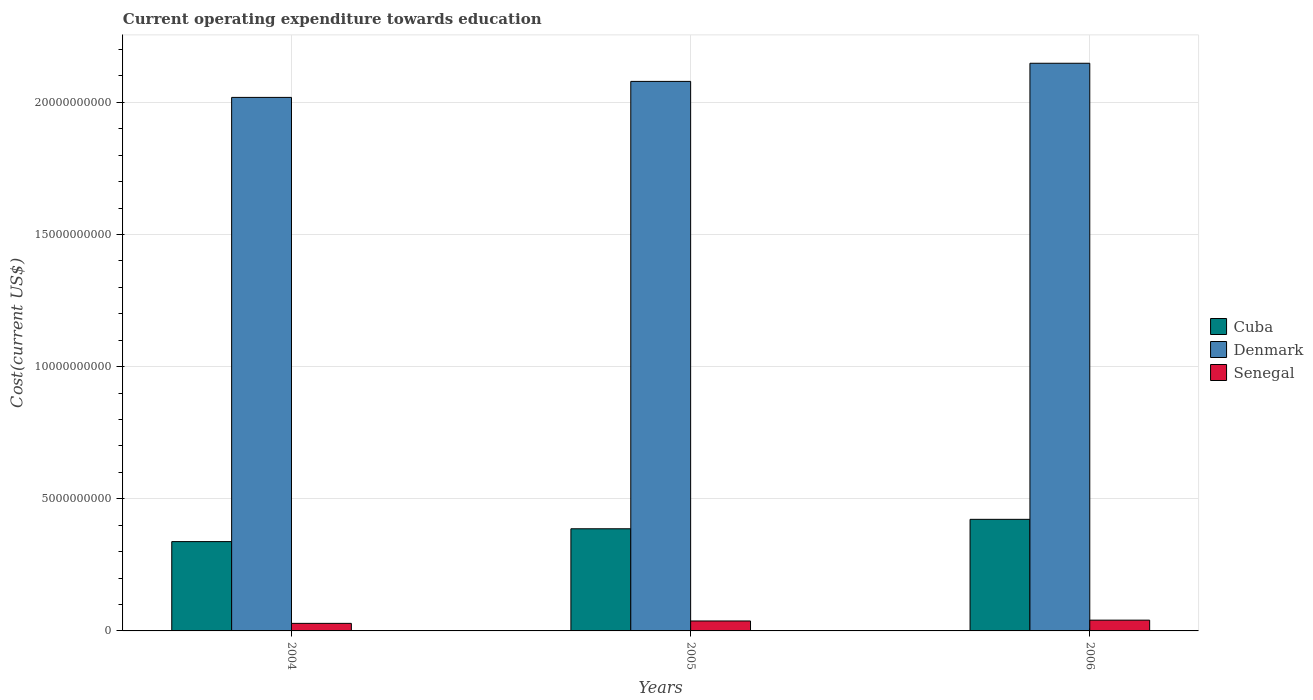How many different coloured bars are there?
Your answer should be compact. 3. How many groups of bars are there?
Provide a succinct answer. 3. Are the number of bars per tick equal to the number of legend labels?
Ensure brevity in your answer.  Yes. How many bars are there on the 3rd tick from the right?
Offer a very short reply. 3. What is the expenditure towards education in Denmark in 2004?
Provide a short and direct response. 2.02e+1. Across all years, what is the maximum expenditure towards education in Senegal?
Provide a succinct answer. 4.08e+08. Across all years, what is the minimum expenditure towards education in Cuba?
Offer a terse response. 3.38e+09. What is the total expenditure towards education in Cuba in the graph?
Your answer should be very brief. 1.15e+1. What is the difference between the expenditure towards education in Denmark in 2005 and that in 2006?
Offer a terse response. -6.87e+08. What is the difference between the expenditure towards education in Denmark in 2005 and the expenditure towards education in Cuba in 2006?
Offer a terse response. 1.66e+1. What is the average expenditure towards education in Denmark per year?
Provide a short and direct response. 2.08e+1. In the year 2004, what is the difference between the expenditure towards education in Cuba and expenditure towards education in Senegal?
Provide a succinct answer. 3.09e+09. What is the ratio of the expenditure towards education in Cuba in 2004 to that in 2005?
Your answer should be very brief. 0.87. Is the difference between the expenditure towards education in Cuba in 2005 and 2006 greater than the difference between the expenditure towards education in Senegal in 2005 and 2006?
Offer a very short reply. No. What is the difference between the highest and the second highest expenditure towards education in Senegal?
Keep it short and to the point. 3.16e+07. What is the difference between the highest and the lowest expenditure towards education in Cuba?
Make the answer very short. 8.42e+08. What does the 3rd bar from the left in 2004 represents?
Offer a very short reply. Senegal. What does the 3rd bar from the right in 2006 represents?
Provide a short and direct response. Cuba. Is it the case that in every year, the sum of the expenditure towards education in Cuba and expenditure towards education in Senegal is greater than the expenditure towards education in Denmark?
Give a very brief answer. No. How many bars are there?
Offer a very short reply. 9. Are all the bars in the graph horizontal?
Your answer should be very brief. No. Where does the legend appear in the graph?
Make the answer very short. Center right. What is the title of the graph?
Make the answer very short. Current operating expenditure towards education. Does "Ethiopia" appear as one of the legend labels in the graph?
Make the answer very short. No. What is the label or title of the X-axis?
Your answer should be very brief. Years. What is the label or title of the Y-axis?
Your answer should be compact. Cost(current US$). What is the Cost(current US$) of Cuba in 2004?
Provide a short and direct response. 3.38e+09. What is the Cost(current US$) of Denmark in 2004?
Keep it short and to the point. 2.02e+1. What is the Cost(current US$) in Senegal in 2004?
Your response must be concise. 2.86e+08. What is the Cost(current US$) in Cuba in 2005?
Make the answer very short. 3.87e+09. What is the Cost(current US$) of Denmark in 2005?
Make the answer very short. 2.08e+1. What is the Cost(current US$) of Senegal in 2005?
Ensure brevity in your answer.  3.76e+08. What is the Cost(current US$) of Cuba in 2006?
Your answer should be very brief. 4.22e+09. What is the Cost(current US$) of Denmark in 2006?
Offer a terse response. 2.15e+1. What is the Cost(current US$) in Senegal in 2006?
Your response must be concise. 4.08e+08. Across all years, what is the maximum Cost(current US$) in Cuba?
Give a very brief answer. 4.22e+09. Across all years, what is the maximum Cost(current US$) of Denmark?
Your answer should be compact. 2.15e+1. Across all years, what is the maximum Cost(current US$) of Senegal?
Offer a very short reply. 4.08e+08. Across all years, what is the minimum Cost(current US$) in Cuba?
Give a very brief answer. 3.38e+09. Across all years, what is the minimum Cost(current US$) in Denmark?
Make the answer very short. 2.02e+1. Across all years, what is the minimum Cost(current US$) of Senegal?
Your response must be concise. 2.86e+08. What is the total Cost(current US$) of Cuba in the graph?
Ensure brevity in your answer.  1.15e+1. What is the total Cost(current US$) in Denmark in the graph?
Your answer should be very brief. 6.25e+1. What is the total Cost(current US$) of Senegal in the graph?
Provide a succinct answer. 1.07e+09. What is the difference between the Cost(current US$) in Cuba in 2004 and that in 2005?
Provide a short and direct response. -4.85e+08. What is the difference between the Cost(current US$) in Denmark in 2004 and that in 2005?
Your response must be concise. -6.05e+08. What is the difference between the Cost(current US$) in Senegal in 2004 and that in 2005?
Your answer should be very brief. -9.04e+07. What is the difference between the Cost(current US$) in Cuba in 2004 and that in 2006?
Give a very brief answer. -8.42e+08. What is the difference between the Cost(current US$) of Denmark in 2004 and that in 2006?
Keep it short and to the point. -1.29e+09. What is the difference between the Cost(current US$) of Senegal in 2004 and that in 2006?
Keep it short and to the point. -1.22e+08. What is the difference between the Cost(current US$) of Cuba in 2005 and that in 2006?
Make the answer very short. -3.57e+08. What is the difference between the Cost(current US$) in Denmark in 2005 and that in 2006?
Keep it short and to the point. -6.87e+08. What is the difference between the Cost(current US$) of Senegal in 2005 and that in 2006?
Offer a terse response. -3.16e+07. What is the difference between the Cost(current US$) of Cuba in 2004 and the Cost(current US$) of Denmark in 2005?
Make the answer very short. -1.74e+1. What is the difference between the Cost(current US$) of Cuba in 2004 and the Cost(current US$) of Senegal in 2005?
Give a very brief answer. 3.00e+09. What is the difference between the Cost(current US$) in Denmark in 2004 and the Cost(current US$) in Senegal in 2005?
Your answer should be very brief. 1.98e+1. What is the difference between the Cost(current US$) of Cuba in 2004 and the Cost(current US$) of Denmark in 2006?
Offer a very short reply. -1.81e+1. What is the difference between the Cost(current US$) in Cuba in 2004 and the Cost(current US$) in Senegal in 2006?
Your response must be concise. 2.97e+09. What is the difference between the Cost(current US$) of Denmark in 2004 and the Cost(current US$) of Senegal in 2006?
Offer a terse response. 1.98e+1. What is the difference between the Cost(current US$) of Cuba in 2005 and the Cost(current US$) of Denmark in 2006?
Your answer should be compact. -1.76e+1. What is the difference between the Cost(current US$) of Cuba in 2005 and the Cost(current US$) of Senegal in 2006?
Provide a succinct answer. 3.46e+09. What is the difference between the Cost(current US$) of Denmark in 2005 and the Cost(current US$) of Senegal in 2006?
Keep it short and to the point. 2.04e+1. What is the average Cost(current US$) in Cuba per year?
Your answer should be very brief. 3.82e+09. What is the average Cost(current US$) in Denmark per year?
Make the answer very short. 2.08e+1. What is the average Cost(current US$) of Senegal per year?
Provide a short and direct response. 3.57e+08. In the year 2004, what is the difference between the Cost(current US$) in Cuba and Cost(current US$) in Denmark?
Your answer should be compact. -1.68e+1. In the year 2004, what is the difference between the Cost(current US$) of Cuba and Cost(current US$) of Senegal?
Provide a short and direct response. 3.09e+09. In the year 2004, what is the difference between the Cost(current US$) in Denmark and Cost(current US$) in Senegal?
Offer a terse response. 1.99e+1. In the year 2005, what is the difference between the Cost(current US$) of Cuba and Cost(current US$) of Denmark?
Your response must be concise. -1.69e+1. In the year 2005, what is the difference between the Cost(current US$) in Cuba and Cost(current US$) in Senegal?
Your answer should be very brief. 3.49e+09. In the year 2005, what is the difference between the Cost(current US$) in Denmark and Cost(current US$) in Senegal?
Your response must be concise. 2.04e+1. In the year 2006, what is the difference between the Cost(current US$) in Cuba and Cost(current US$) in Denmark?
Offer a terse response. -1.73e+1. In the year 2006, what is the difference between the Cost(current US$) in Cuba and Cost(current US$) in Senegal?
Your answer should be very brief. 3.81e+09. In the year 2006, what is the difference between the Cost(current US$) of Denmark and Cost(current US$) of Senegal?
Provide a short and direct response. 2.11e+1. What is the ratio of the Cost(current US$) in Cuba in 2004 to that in 2005?
Provide a short and direct response. 0.87. What is the ratio of the Cost(current US$) of Denmark in 2004 to that in 2005?
Provide a short and direct response. 0.97. What is the ratio of the Cost(current US$) of Senegal in 2004 to that in 2005?
Your answer should be compact. 0.76. What is the ratio of the Cost(current US$) of Cuba in 2004 to that in 2006?
Keep it short and to the point. 0.8. What is the ratio of the Cost(current US$) of Denmark in 2004 to that in 2006?
Offer a very short reply. 0.94. What is the ratio of the Cost(current US$) in Senegal in 2004 to that in 2006?
Ensure brevity in your answer.  0.7. What is the ratio of the Cost(current US$) in Cuba in 2005 to that in 2006?
Give a very brief answer. 0.92. What is the ratio of the Cost(current US$) of Senegal in 2005 to that in 2006?
Keep it short and to the point. 0.92. What is the difference between the highest and the second highest Cost(current US$) of Cuba?
Offer a terse response. 3.57e+08. What is the difference between the highest and the second highest Cost(current US$) in Denmark?
Your response must be concise. 6.87e+08. What is the difference between the highest and the second highest Cost(current US$) of Senegal?
Make the answer very short. 3.16e+07. What is the difference between the highest and the lowest Cost(current US$) in Cuba?
Offer a terse response. 8.42e+08. What is the difference between the highest and the lowest Cost(current US$) in Denmark?
Your answer should be compact. 1.29e+09. What is the difference between the highest and the lowest Cost(current US$) in Senegal?
Your answer should be compact. 1.22e+08. 